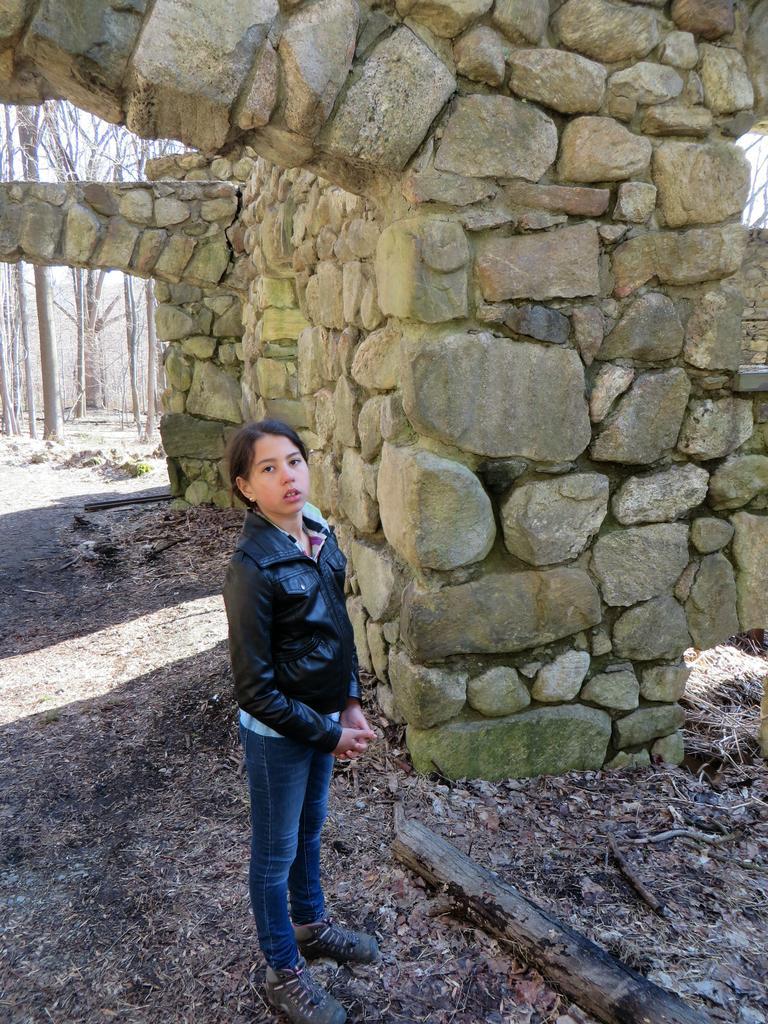Describe this image in one or two sentences. In this image, we can see a kid wearing clothes and standing beside an arch. There is an another arch and some trees in the top left of the image. 